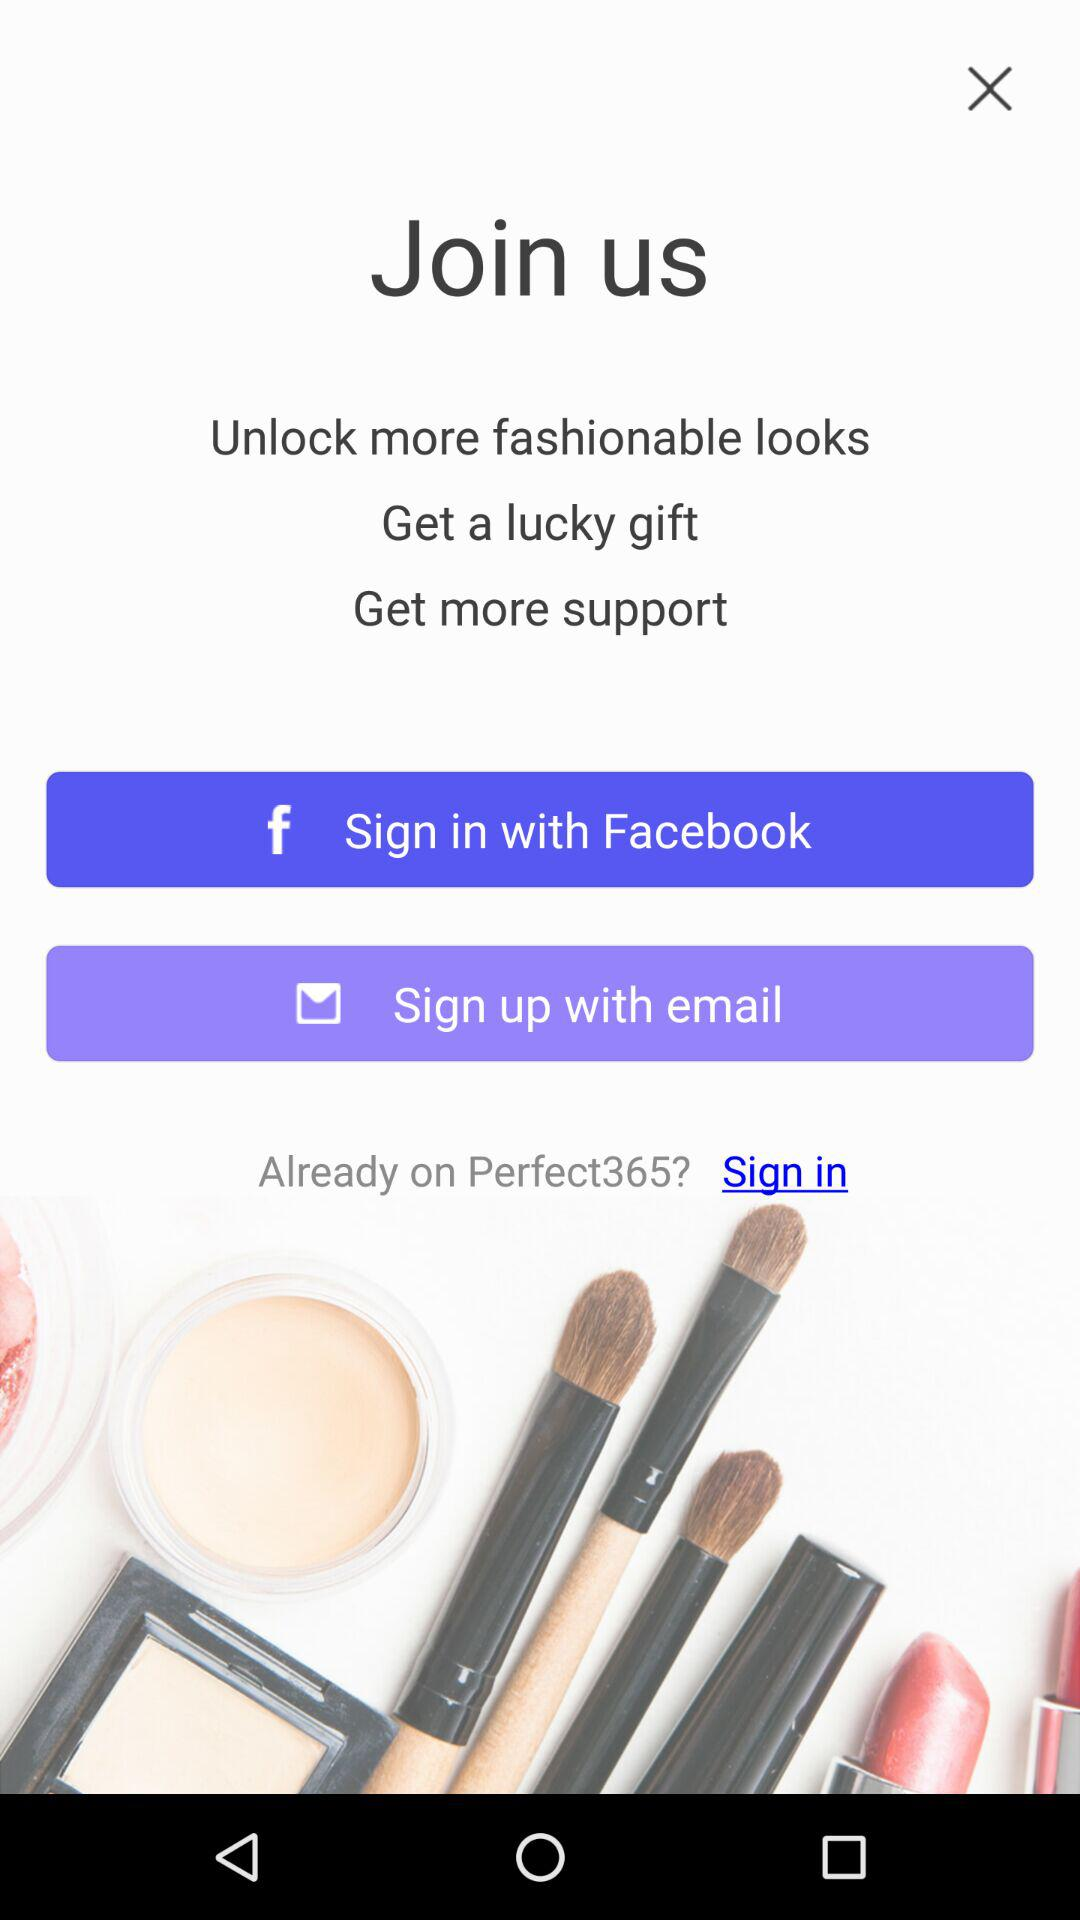What account can I use to sign in? The accounts that you can use to sign in are "Facebook" and "email". 